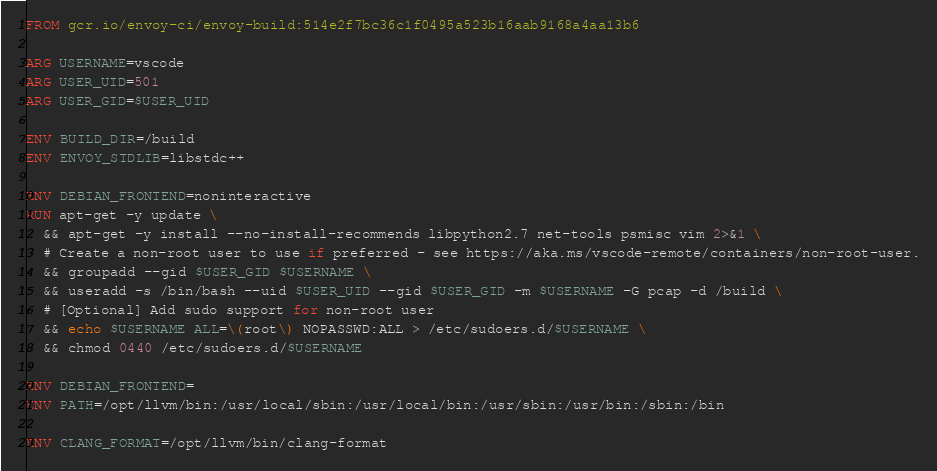<code> <loc_0><loc_0><loc_500><loc_500><_Dockerfile_>FROM gcr.io/envoy-ci/envoy-build:514e2f7bc36c1f0495a523b16aab9168a4aa13b6

ARG USERNAME=vscode
ARG USER_UID=501
ARG USER_GID=$USER_UID

ENV BUILD_DIR=/build
ENV ENVOY_STDLIB=libstdc++

ENV DEBIAN_FRONTEND=noninteractive
RUN apt-get -y update \
  && apt-get -y install --no-install-recommends libpython2.7 net-tools psmisc vim 2>&1 \
  # Create a non-root user to use if preferred - see https://aka.ms/vscode-remote/containers/non-root-user.
  && groupadd --gid $USER_GID $USERNAME \
  && useradd -s /bin/bash --uid $USER_UID --gid $USER_GID -m $USERNAME -G pcap -d /build \
  # [Optional] Add sudo support for non-root user
  && echo $USERNAME ALL=\(root\) NOPASSWD:ALL > /etc/sudoers.d/$USERNAME \
  && chmod 0440 /etc/sudoers.d/$USERNAME

ENV DEBIAN_FRONTEND=
ENV PATH=/opt/llvm/bin:/usr/local/sbin:/usr/local/bin:/usr/sbin:/usr/bin:/sbin:/bin

ENV CLANG_FORMAT=/opt/llvm/bin/clang-format
</code> 